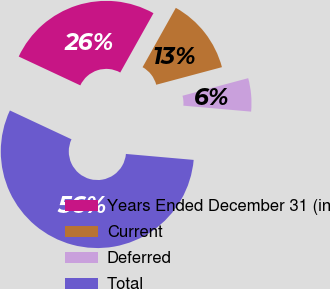<chart> <loc_0><loc_0><loc_500><loc_500><pie_chart><fcel>Years Ended December 31 (in<fcel>Current<fcel>Deferred<fcel>Total<nl><fcel>26.16%<fcel>12.71%<fcel>5.56%<fcel>55.57%<nl></chart> 